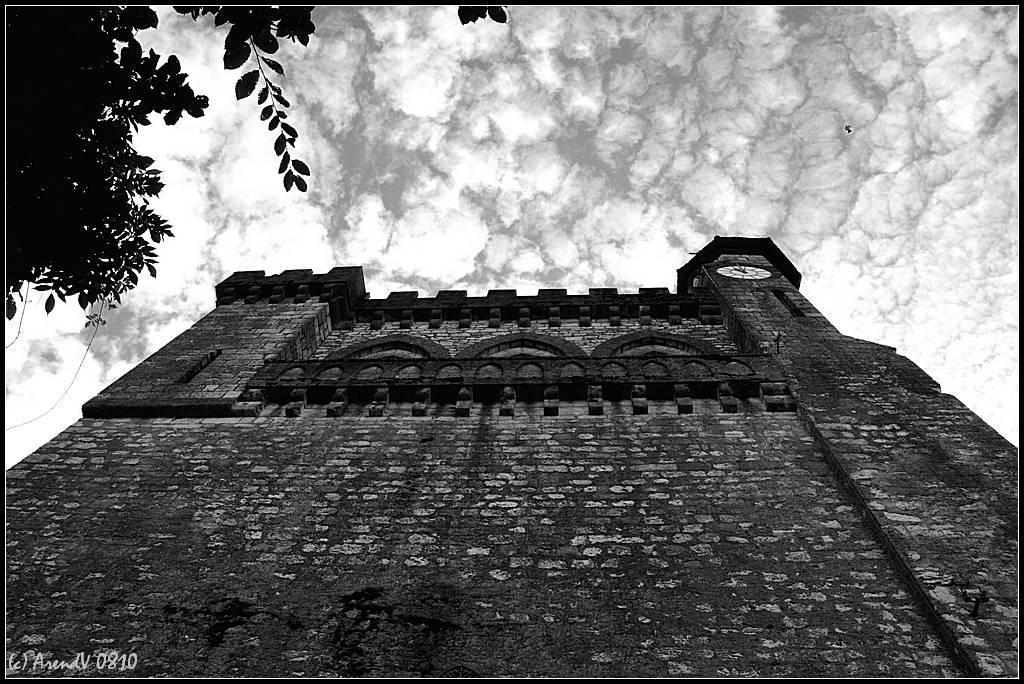What type of structure is present in the image? There is a building in the image. What other natural element can be seen in the image? There is a tree in the image. What is visible in the background of the image? Clouds and the sky are visible in the background of the image. What type of punishment is being handed out to the kittens in the image? There are no kittens present in the image, so no punishment is being handed out. Where is the drawer located in the image? There is no drawer present in the image. 